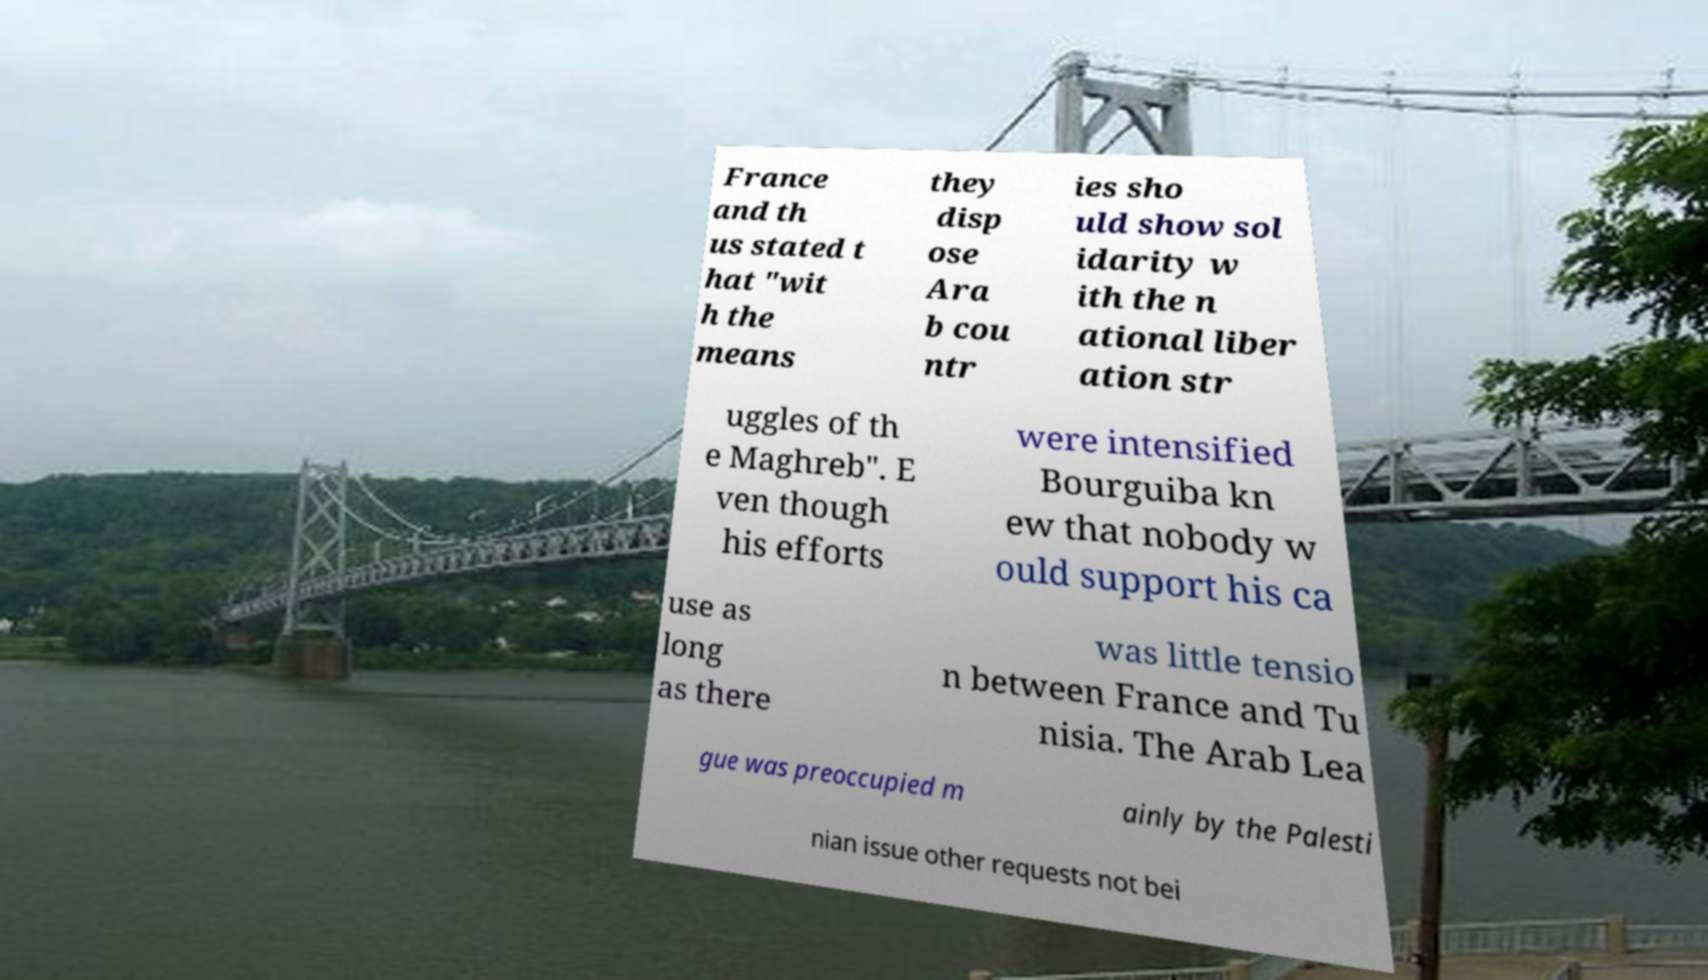Can you read and provide the text displayed in the image?This photo seems to have some interesting text. Can you extract and type it out for me? France and th us stated t hat "wit h the means they disp ose Ara b cou ntr ies sho uld show sol idarity w ith the n ational liber ation str uggles of th e Maghreb". E ven though his efforts were intensified Bourguiba kn ew that nobody w ould support his ca use as long as there was little tensio n between France and Tu nisia. The Arab Lea gue was preoccupied m ainly by the Palesti nian issue other requests not bei 